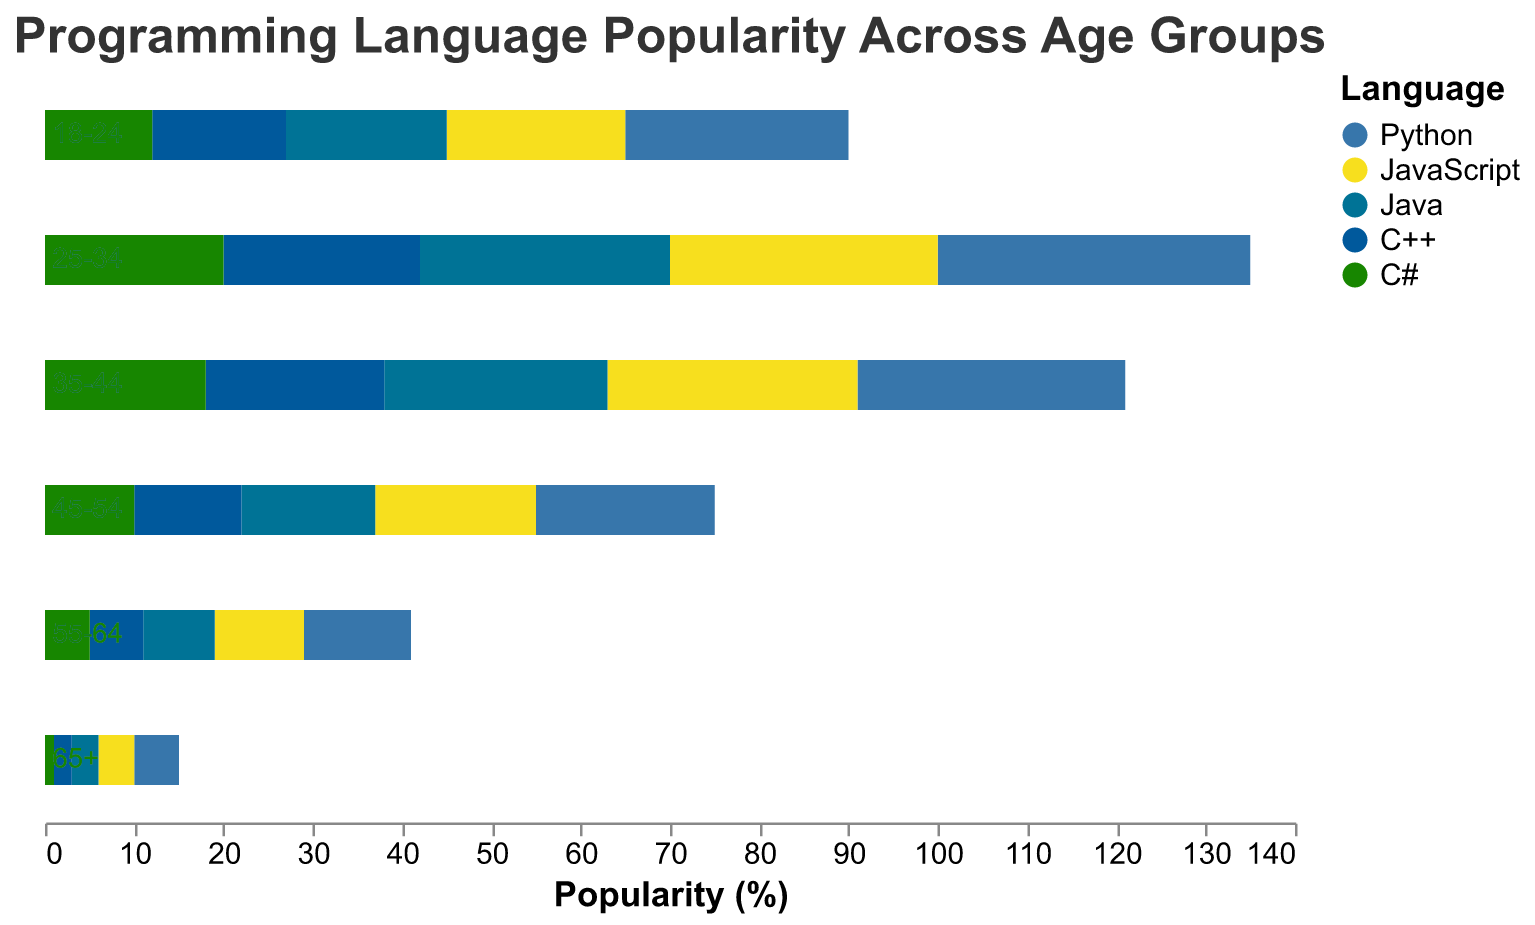What is the title of the figure? The title is at the top of the figure, and it reads "Programming Language Popularity Across Age Groups."
Answer: Programming Language Popularity Across Age Groups What is the most popular programming language among the 18-24 age group? The bar for JavaScript extends furthest to the right for the 18-24 age group, indicating that it is the most popular.
Answer: JavaScript Which age group shows the highest popularity for Python? By looking at the bars on the left side of the figure, the age group 25-34 has the longest negative bar for Python, indicating the highest popularity.
Answer: 25-34 Between Java and C++, which language is more popular among the 35-44 age group? Comparing the lengths of the bars for Java and C++ within the 35-44 age group, the bar for C++ extends further, indicating higher popularity.
Answer: C++ How does the popularity of C++ change with age? Observing the bars for C++ across different age groups, the popularity decreases as age increases.
Answer: Decreases with age For which age group is the difference in popularity between JavaScript and Python the greatest? By calculating the difference in bar lengths for JavaScript and Python in each age group, the 25-34 group shows the greatest difference since JavaScript is 30 and Python is -35, making the absolute difference 65.
Answer: 25-34 Among people aged 55-64, which language is the least popular? The shortest bar for the 55-64 age group belongs to C#, indicating its low popularity.
Answer: C# Are there any age groups where C# is more popular than JavaScript? By examining the bars, in all age groups, the JavaScript bar is always longer than the C# bar, showing no age group with higher C# popularity than JavaScript.
Answer: No What's the combined popularity of Python and Java for the 45-54 age group? Summing the absolute values of the Python (-20) and Java (-15) bars for the 45-54 age group, the combined popularity is 35.
Answer: 35 Which language has consistent popularity among all age groups? By looking at the bars of each language across all age groups, JavaScript's bars are relatively consistent without drastic changes.
Answer: JavaScript 